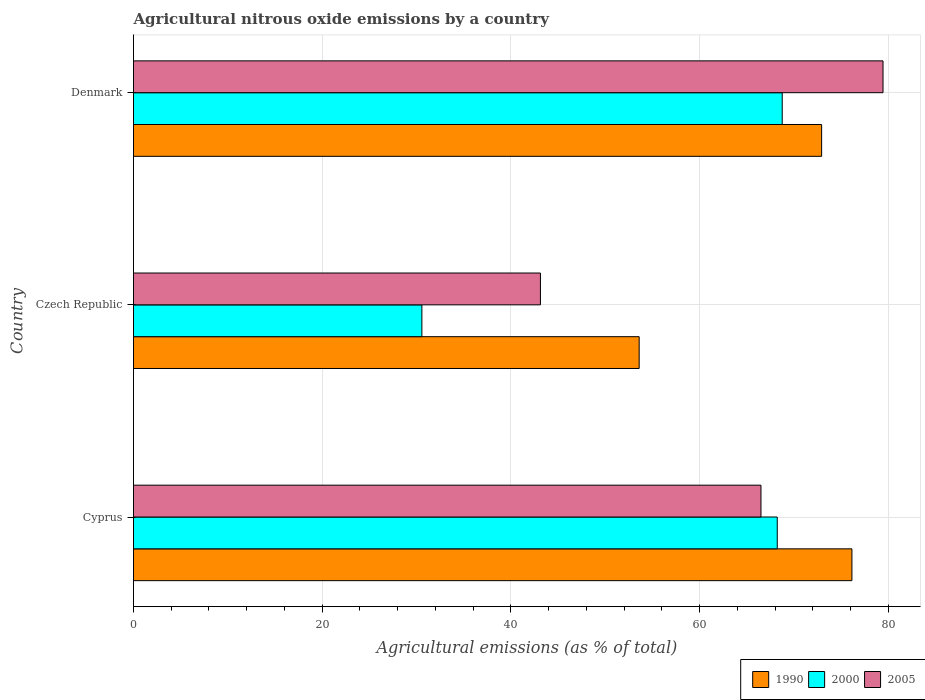How many different coloured bars are there?
Offer a terse response. 3. How many groups of bars are there?
Provide a short and direct response. 3. Are the number of bars per tick equal to the number of legend labels?
Offer a very short reply. Yes. How many bars are there on the 3rd tick from the top?
Provide a short and direct response. 3. What is the label of the 1st group of bars from the top?
Your answer should be compact. Denmark. What is the amount of agricultural nitrous oxide emitted in 2005 in Cyprus?
Make the answer very short. 66.5. Across all countries, what is the maximum amount of agricultural nitrous oxide emitted in 2005?
Keep it short and to the point. 79.44. Across all countries, what is the minimum amount of agricultural nitrous oxide emitted in 2000?
Offer a very short reply. 30.56. In which country was the amount of agricultural nitrous oxide emitted in 2000 minimum?
Give a very brief answer. Czech Republic. What is the total amount of agricultural nitrous oxide emitted in 1990 in the graph?
Offer a terse response. 202.67. What is the difference between the amount of agricultural nitrous oxide emitted in 2005 in Czech Republic and that in Denmark?
Ensure brevity in your answer.  -36.31. What is the difference between the amount of agricultural nitrous oxide emitted in 2005 in Denmark and the amount of agricultural nitrous oxide emitted in 1990 in Cyprus?
Keep it short and to the point. 3.3. What is the average amount of agricultural nitrous oxide emitted in 1990 per country?
Your answer should be very brief. 67.56. What is the difference between the amount of agricultural nitrous oxide emitted in 2005 and amount of agricultural nitrous oxide emitted in 2000 in Denmark?
Ensure brevity in your answer.  10.68. In how many countries, is the amount of agricultural nitrous oxide emitted in 2005 greater than 16 %?
Offer a very short reply. 3. What is the ratio of the amount of agricultural nitrous oxide emitted in 1990 in Cyprus to that in Czech Republic?
Offer a terse response. 1.42. What is the difference between the highest and the second highest amount of agricultural nitrous oxide emitted in 2000?
Your answer should be very brief. 0.53. What is the difference between the highest and the lowest amount of agricultural nitrous oxide emitted in 1990?
Your answer should be compact. 22.55. In how many countries, is the amount of agricultural nitrous oxide emitted in 1990 greater than the average amount of agricultural nitrous oxide emitted in 1990 taken over all countries?
Offer a terse response. 2. Is the sum of the amount of agricultural nitrous oxide emitted in 1990 in Cyprus and Denmark greater than the maximum amount of agricultural nitrous oxide emitted in 2000 across all countries?
Offer a very short reply. Yes. What does the 2nd bar from the top in Denmark represents?
Offer a very short reply. 2000. Is it the case that in every country, the sum of the amount of agricultural nitrous oxide emitted in 2000 and amount of agricultural nitrous oxide emitted in 1990 is greater than the amount of agricultural nitrous oxide emitted in 2005?
Keep it short and to the point. Yes. Are all the bars in the graph horizontal?
Provide a short and direct response. Yes. What is the title of the graph?
Give a very brief answer. Agricultural nitrous oxide emissions by a country. What is the label or title of the X-axis?
Provide a short and direct response. Agricultural emissions (as % of total). What is the label or title of the Y-axis?
Make the answer very short. Country. What is the Agricultural emissions (as % of total) of 1990 in Cyprus?
Keep it short and to the point. 76.14. What is the Agricultural emissions (as % of total) in 2000 in Cyprus?
Offer a terse response. 68.23. What is the Agricultural emissions (as % of total) in 2005 in Cyprus?
Offer a very short reply. 66.5. What is the Agricultural emissions (as % of total) of 1990 in Czech Republic?
Your answer should be very brief. 53.6. What is the Agricultural emissions (as % of total) in 2000 in Czech Republic?
Make the answer very short. 30.56. What is the Agricultural emissions (as % of total) in 2005 in Czech Republic?
Make the answer very short. 43.13. What is the Agricultural emissions (as % of total) in 1990 in Denmark?
Provide a short and direct response. 72.93. What is the Agricultural emissions (as % of total) of 2000 in Denmark?
Offer a terse response. 68.76. What is the Agricultural emissions (as % of total) of 2005 in Denmark?
Your answer should be very brief. 79.44. Across all countries, what is the maximum Agricultural emissions (as % of total) of 1990?
Ensure brevity in your answer.  76.14. Across all countries, what is the maximum Agricultural emissions (as % of total) in 2000?
Provide a succinct answer. 68.76. Across all countries, what is the maximum Agricultural emissions (as % of total) in 2005?
Provide a short and direct response. 79.44. Across all countries, what is the minimum Agricultural emissions (as % of total) in 1990?
Ensure brevity in your answer.  53.6. Across all countries, what is the minimum Agricultural emissions (as % of total) in 2000?
Your answer should be very brief. 30.56. Across all countries, what is the minimum Agricultural emissions (as % of total) in 2005?
Make the answer very short. 43.13. What is the total Agricultural emissions (as % of total) of 1990 in the graph?
Your answer should be compact. 202.67. What is the total Agricultural emissions (as % of total) of 2000 in the graph?
Keep it short and to the point. 167.55. What is the total Agricultural emissions (as % of total) of 2005 in the graph?
Offer a terse response. 189.08. What is the difference between the Agricultural emissions (as % of total) in 1990 in Cyprus and that in Czech Republic?
Give a very brief answer. 22.55. What is the difference between the Agricultural emissions (as % of total) in 2000 in Cyprus and that in Czech Republic?
Offer a terse response. 37.67. What is the difference between the Agricultural emissions (as % of total) of 2005 in Cyprus and that in Czech Republic?
Offer a very short reply. 23.37. What is the difference between the Agricultural emissions (as % of total) of 1990 in Cyprus and that in Denmark?
Give a very brief answer. 3.21. What is the difference between the Agricultural emissions (as % of total) in 2000 in Cyprus and that in Denmark?
Give a very brief answer. -0.53. What is the difference between the Agricultural emissions (as % of total) of 2005 in Cyprus and that in Denmark?
Give a very brief answer. -12.94. What is the difference between the Agricultural emissions (as % of total) in 1990 in Czech Republic and that in Denmark?
Offer a terse response. -19.34. What is the difference between the Agricultural emissions (as % of total) of 2000 in Czech Republic and that in Denmark?
Your answer should be compact. -38.19. What is the difference between the Agricultural emissions (as % of total) of 2005 in Czech Republic and that in Denmark?
Ensure brevity in your answer.  -36.31. What is the difference between the Agricultural emissions (as % of total) in 1990 in Cyprus and the Agricultural emissions (as % of total) in 2000 in Czech Republic?
Make the answer very short. 45.58. What is the difference between the Agricultural emissions (as % of total) in 1990 in Cyprus and the Agricultural emissions (as % of total) in 2005 in Czech Republic?
Provide a short and direct response. 33.01. What is the difference between the Agricultural emissions (as % of total) in 2000 in Cyprus and the Agricultural emissions (as % of total) in 2005 in Czech Republic?
Ensure brevity in your answer.  25.1. What is the difference between the Agricultural emissions (as % of total) in 1990 in Cyprus and the Agricultural emissions (as % of total) in 2000 in Denmark?
Provide a short and direct response. 7.39. What is the difference between the Agricultural emissions (as % of total) in 1990 in Cyprus and the Agricultural emissions (as % of total) in 2005 in Denmark?
Offer a terse response. -3.3. What is the difference between the Agricultural emissions (as % of total) of 2000 in Cyprus and the Agricultural emissions (as % of total) of 2005 in Denmark?
Make the answer very short. -11.21. What is the difference between the Agricultural emissions (as % of total) of 1990 in Czech Republic and the Agricultural emissions (as % of total) of 2000 in Denmark?
Offer a very short reply. -15.16. What is the difference between the Agricultural emissions (as % of total) of 1990 in Czech Republic and the Agricultural emissions (as % of total) of 2005 in Denmark?
Make the answer very short. -25.85. What is the difference between the Agricultural emissions (as % of total) of 2000 in Czech Republic and the Agricultural emissions (as % of total) of 2005 in Denmark?
Offer a terse response. -48.88. What is the average Agricultural emissions (as % of total) of 1990 per country?
Keep it short and to the point. 67.56. What is the average Agricultural emissions (as % of total) in 2000 per country?
Provide a succinct answer. 55.85. What is the average Agricultural emissions (as % of total) of 2005 per country?
Your response must be concise. 63.03. What is the difference between the Agricultural emissions (as % of total) of 1990 and Agricultural emissions (as % of total) of 2000 in Cyprus?
Your answer should be very brief. 7.92. What is the difference between the Agricultural emissions (as % of total) of 1990 and Agricultural emissions (as % of total) of 2005 in Cyprus?
Offer a terse response. 9.64. What is the difference between the Agricultural emissions (as % of total) in 2000 and Agricultural emissions (as % of total) in 2005 in Cyprus?
Keep it short and to the point. 1.73. What is the difference between the Agricultural emissions (as % of total) of 1990 and Agricultural emissions (as % of total) of 2000 in Czech Republic?
Provide a succinct answer. 23.03. What is the difference between the Agricultural emissions (as % of total) in 1990 and Agricultural emissions (as % of total) in 2005 in Czech Republic?
Make the answer very short. 10.47. What is the difference between the Agricultural emissions (as % of total) of 2000 and Agricultural emissions (as % of total) of 2005 in Czech Republic?
Your answer should be very brief. -12.57. What is the difference between the Agricultural emissions (as % of total) in 1990 and Agricultural emissions (as % of total) in 2000 in Denmark?
Offer a very short reply. 4.18. What is the difference between the Agricultural emissions (as % of total) in 1990 and Agricultural emissions (as % of total) in 2005 in Denmark?
Provide a succinct answer. -6.51. What is the difference between the Agricultural emissions (as % of total) of 2000 and Agricultural emissions (as % of total) of 2005 in Denmark?
Ensure brevity in your answer.  -10.68. What is the ratio of the Agricultural emissions (as % of total) of 1990 in Cyprus to that in Czech Republic?
Your answer should be very brief. 1.42. What is the ratio of the Agricultural emissions (as % of total) of 2000 in Cyprus to that in Czech Republic?
Your answer should be compact. 2.23. What is the ratio of the Agricultural emissions (as % of total) in 2005 in Cyprus to that in Czech Republic?
Ensure brevity in your answer.  1.54. What is the ratio of the Agricultural emissions (as % of total) in 1990 in Cyprus to that in Denmark?
Provide a succinct answer. 1.04. What is the ratio of the Agricultural emissions (as % of total) in 2005 in Cyprus to that in Denmark?
Offer a very short reply. 0.84. What is the ratio of the Agricultural emissions (as % of total) in 1990 in Czech Republic to that in Denmark?
Provide a succinct answer. 0.73. What is the ratio of the Agricultural emissions (as % of total) of 2000 in Czech Republic to that in Denmark?
Offer a very short reply. 0.44. What is the ratio of the Agricultural emissions (as % of total) of 2005 in Czech Republic to that in Denmark?
Give a very brief answer. 0.54. What is the difference between the highest and the second highest Agricultural emissions (as % of total) in 1990?
Your answer should be compact. 3.21. What is the difference between the highest and the second highest Agricultural emissions (as % of total) in 2000?
Make the answer very short. 0.53. What is the difference between the highest and the second highest Agricultural emissions (as % of total) of 2005?
Make the answer very short. 12.94. What is the difference between the highest and the lowest Agricultural emissions (as % of total) of 1990?
Offer a terse response. 22.55. What is the difference between the highest and the lowest Agricultural emissions (as % of total) of 2000?
Provide a succinct answer. 38.19. What is the difference between the highest and the lowest Agricultural emissions (as % of total) in 2005?
Give a very brief answer. 36.31. 